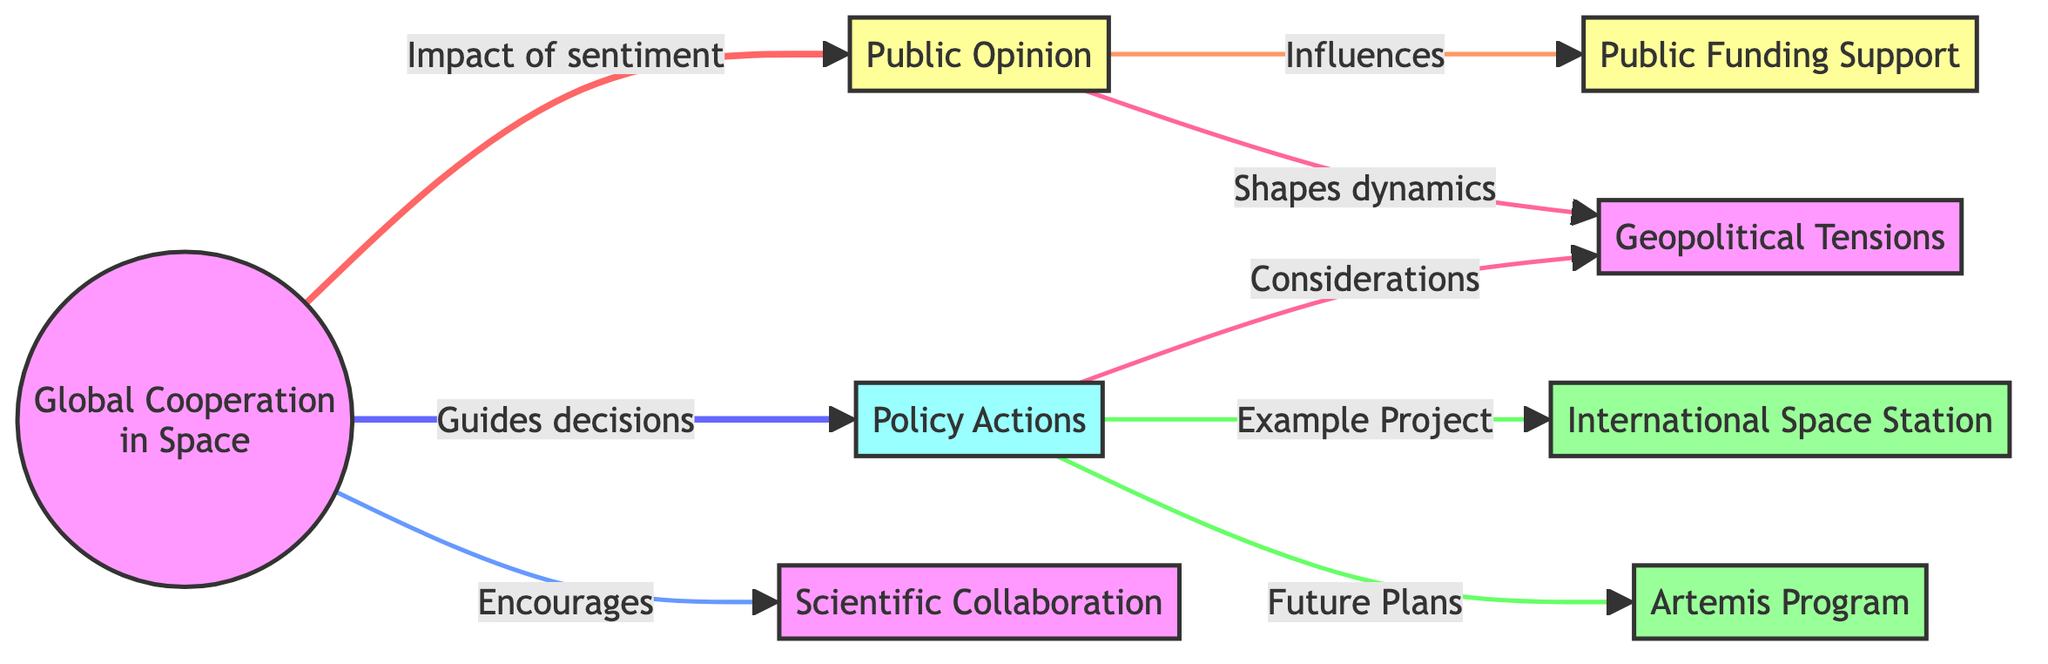What are the two main branches derived from Global Cooperation in Space? The diagram shows two main branches stemming from "Global Cooperation in Space": "Public Opinion" and "Policy Actions". These branches represent the different influences on global space initiatives.
Answer: Public Opinion, Policy Actions How many projects are mentioned in the diagram? In the diagram, there are two defined projects: "International Space Station" and "Artemis Program". By counting the nodes related to projects, we find there are a total of two.
Answer: 2 Which node illustrates an incentive for collaboration beyond public sentiment? The node "Scientific Collaboration" is shown under "Global Cooperation in Space" as an encouragement that stems from global cooperation efforts. It indicates that such collaboration is a positive outcome associated with these efforts.
Answer: Scientific Collaboration What type of tension is mentioned that influences both public opinion and policy actions? The diagram specifically cites "Geopolitical Tensions," indicating that these tensions impact the dynamics between public sentiment and the policies that are enacted regarding space exploration.
Answer: Geopolitical Tensions What influences public funding support according to the diagram? "Public Opinion" influences "Public Funding Support," as indicated in the diagram. This shows how the sentiments of the public can directly affect the financial backing for space initiatives.
Answer: Public Opinion In the diagram, which project is an example of policy actions? The "International Space Station" is identified as an "Example Project" under "Policy Actions," highlighting it as a concrete instance of a policy driving international collaboration in space exploration.
Answer: International Space Station Which element of the diagram is described as shaping the dynamics of cooperation? "Public Opinion" is noted as shaping the dynamics of cooperation, indicating its significant role in how global space initiatives are advanced or altered by public sentiment.
Answer: Public Opinion How does "Public Opinion" relate to "Geopolitical Tensions"? The diagram shows that "Public Opinion" and "Geopolitical Tensions" are both affected by the "Global Cooperation in Space," demonstrating that public sentiment can influence how these tensions are perceived and addressed.
Answer: Shapes dynamics What is the primary action taken by policy actions towards the Artemis Program? The diagram labels the Artemis Program as "Future Plans," which suggests that it is a planned initiative reflecting the decisions made by policy actions concerning space exploration.
Answer: Future Plans 